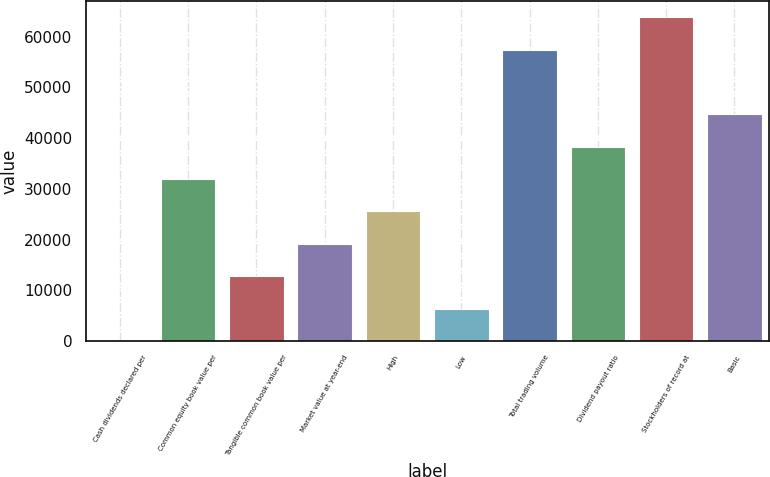Convert chart. <chart><loc_0><loc_0><loc_500><loc_500><bar_chart><fcel>Cash dividends declared per<fcel>Common equity book value per<fcel>Tangible common book value per<fcel>Market value at year-end<fcel>High<fcel>Low<fcel>Total trading volume<fcel>Dividend payout ratio<fcel>Stockholders of record at<fcel>Basic<nl><fcel>0.1<fcel>31907.5<fcel>12763.1<fcel>19144.6<fcel>25526.1<fcel>6381.59<fcel>57433.5<fcel>38289<fcel>63815<fcel>44670.5<nl></chart> 